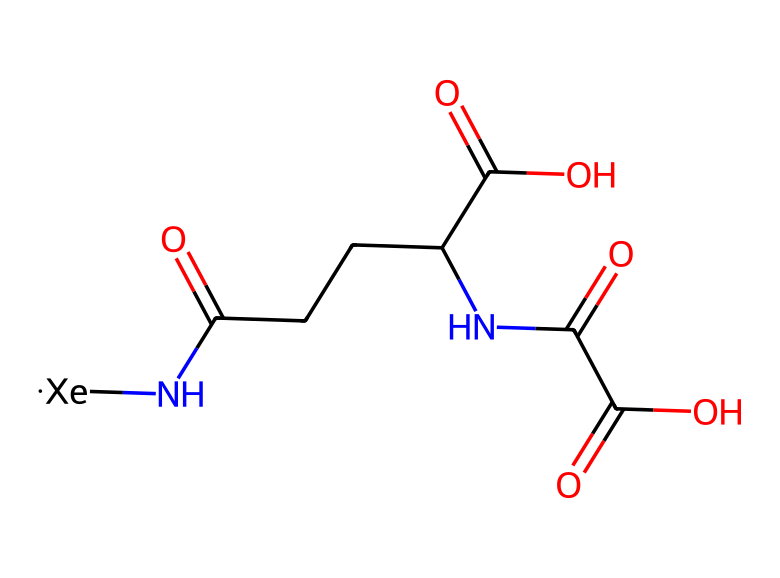What is the central atom in this structure? This chemical contains xenon as indicated by the notation [Xe] in the structure. It is the main element that contributes to its unique properties.
Answer: xenon How many carbon atoms are present in this molecule? By analyzing the structure, we can count a total of 5 carbon atoms found in the chains and functional groups attached to the molecule.
Answer: 5 Which functional groups are featured in this compound? The presence of carboxylic acid groups (-COOH) and an amine group (-NH-) can be detected within the structure. These functional groups are responsible for various reactivity and interactions.
Answer: carboxylic acid and amine What type of chemical bonds are primarily present in this structure? The structure has predominantly covalent bonds, which are evident from the connections between nonmetals (like C, O, N, Xe) indicating shared electron pairs.
Answer: covalent bonds What is the likely role of xenon in this molecular structure? Xenon acts as a contrast agent in medical imaging due to its high atomic number, which enhances the visibility of tissues in imaging techniques like CT scans.
Answer: contrast agent How many oxygen atoms are present in the molecule? Upon examining the molecule, we can find a total of 4 oxygen atoms, which are part of the functional groups and carbon backbone present in the structure.
Answer: 4 Does this compound have basic properties due to its functional groups? Yes, due to the presence of the carboxylic and amine groups, the compound exhibits both acidic and basic properties, contributing to its overall reactivity.
Answer: yes 